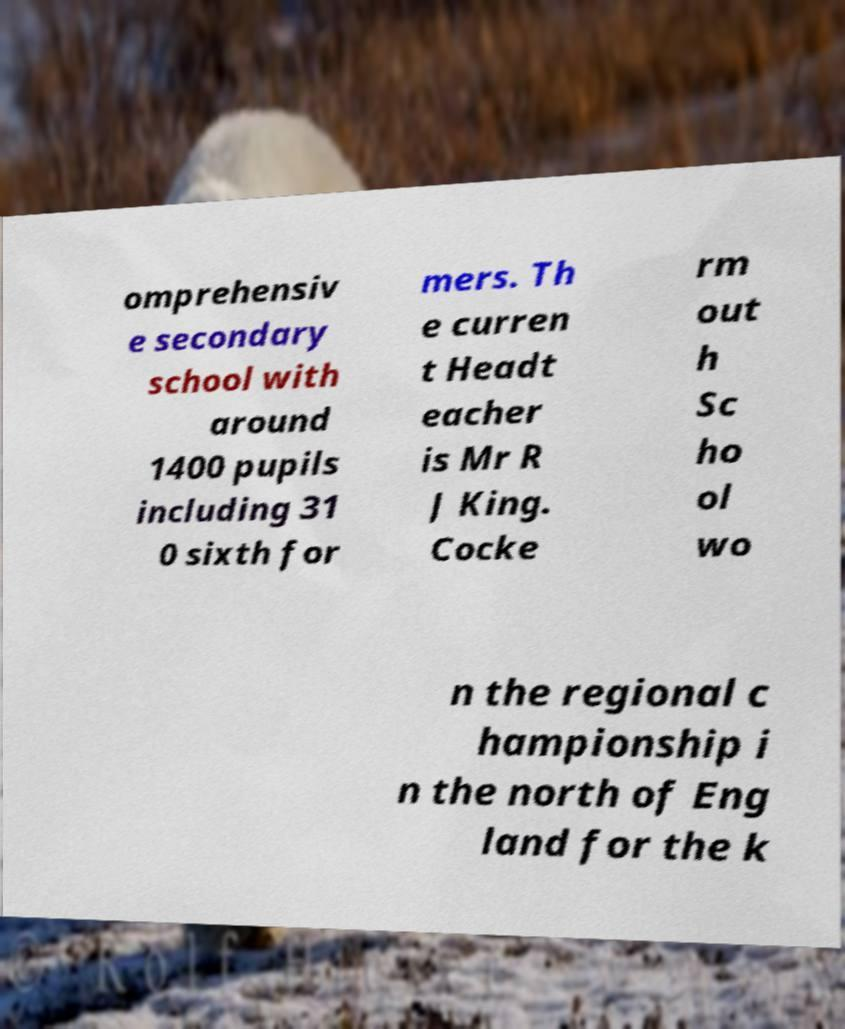For documentation purposes, I need the text within this image transcribed. Could you provide that? omprehensiv e secondary school with around 1400 pupils including 31 0 sixth for mers. Th e curren t Headt eacher is Mr R J King. Cocke rm out h Sc ho ol wo n the regional c hampionship i n the north of Eng land for the k 